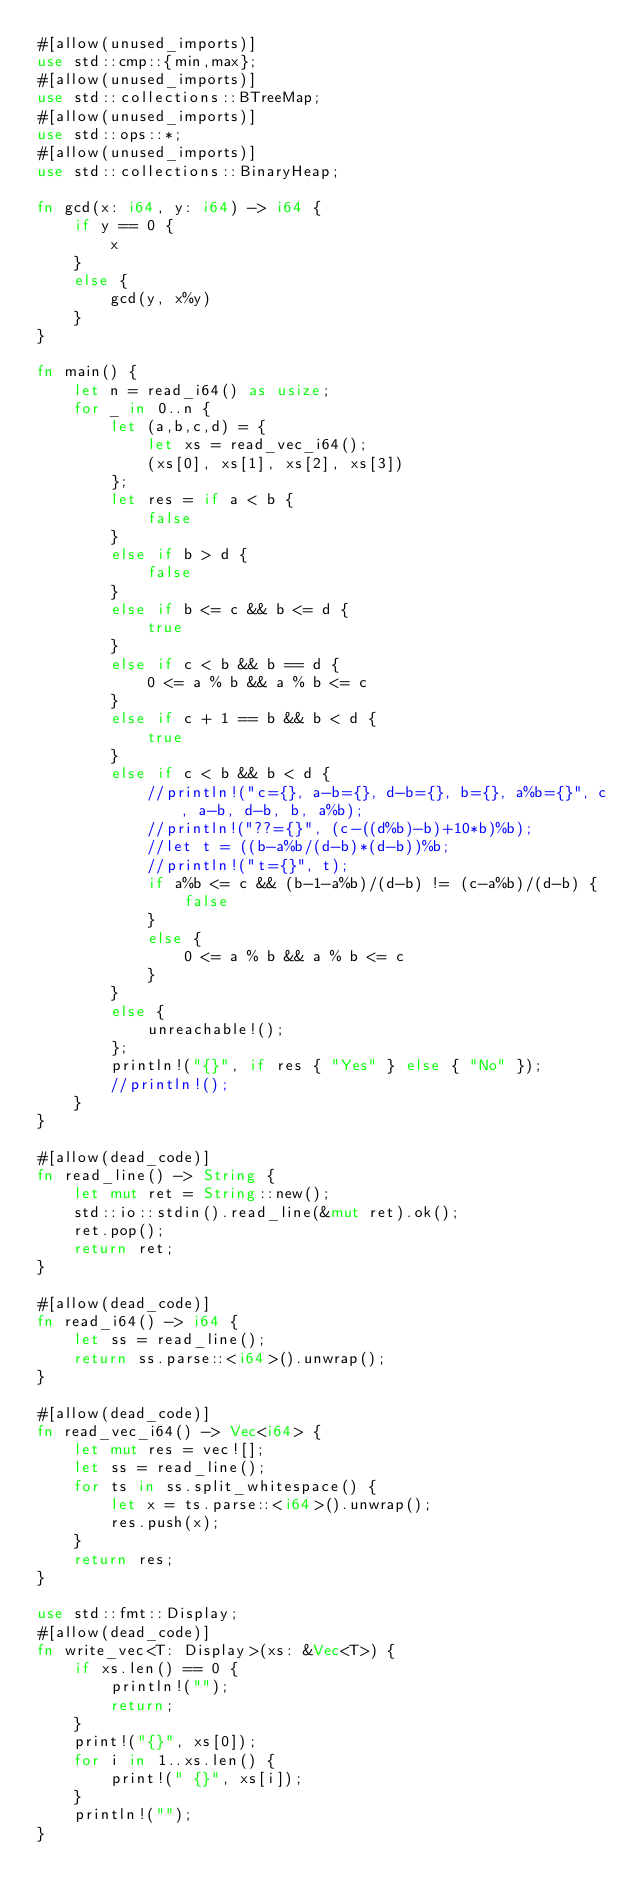<code> <loc_0><loc_0><loc_500><loc_500><_Rust_>#[allow(unused_imports)]
use std::cmp::{min,max};
#[allow(unused_imports)]
use std::collections::BTreeMap;
#[allow(unused_imports)]
use std::ops::*;
#[allow(unused_imports)]
use std::collections::BinaryHeap;

fn gcd(x: i64, y: i64) -> i64 {
    if y == 0 {
        x
    }
    else {
        gcd(y, x%y)
    }
}

fn main() {
    let n = read_i64() as usize;
    for _ in 0..n {
        let (a,b,c,d) = {
            let xs = read_vec_i64();
            (xs[0], xs[1], xs[2], xs[3])
        };
        let res = if a < b {
            false
        }
        else if b > d {
            false
        }
        else if b <= c && b <= d {
            true
        }
        else if c < b && b == d {
            0 <= a % b && a % b <= c
        }
        else if c + 1 == b && b < d {
            true
        }
        else if c < b && b < d {
            //println!("c={}, a-b={}, d-b={}, b={}, a%b={}", c, a-b, d-b, b, a%b);
            //println!("??={}", (c-((d%b)-b)+10*b)%b);
            //let t = ((b-a%b/(d-b)*(d-b))%b;
            //println!("t={}", t);
            if a%b <= c && (b-1-a%b)/(d-b) != (c-a%b)/(d-b) {
                false
            }
            else {
                0 <= a % b && a % b <= c
            }
        }
        else {
            unreachable!();
        };
        println!("{}", if res { "Yes" } else { "No" });
        //println!();
    }
}

#[allow(dead_code)]
fn read_line() -> String {
    let mut ret = String::new();
    std::io::stdin().read_line(&mut ret).ok();
    ret.pop();
    return ret;
}

#[allow(dead_code)]
fn read_i64() -> i64 {
    let ss = read_line();
    return ss.parse::<i64>().unwrap();
}

#[allow(dead_code)]
fn read_vec_i64() -> Vec<i64> {
    let mut res = vec![];
    let ss = read_line();
    for ts in ss.split_whitespace() {
        let x = ts.parse::<i64>().unwrap();
        res.push(x);
    }
    return res;
}

use std::fmt::Display;
#[allow(dead_code)]
fn write_vec<T: Display>(xs: &Vec<T>) {
    if xs.len() == 0 {
        println!("");
        return;
    }
    print!("{}", xs[0]);
    for i in 1..xs.len() {
        print!(" {}", xs[i]);
    }
    println!("");
}
</code> 